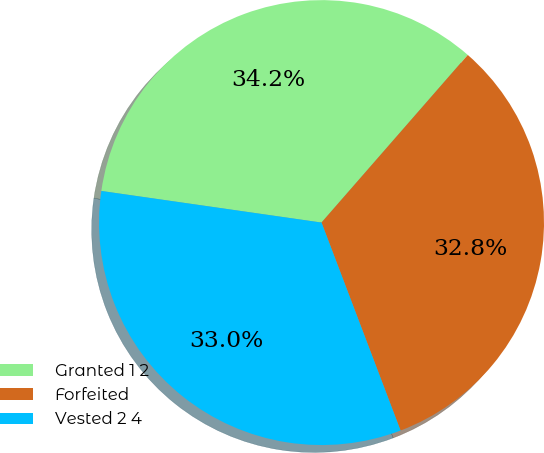Convert chart to OTSL. <chart><loc_0><loc_0><loc_500><loc_500><pie_chart><fcel>Granted 1 2<fcel>Forfeited<fcel>Vested 2 4<nl><fcel>34.15%<fcel>32.8%<fcel>33.05%<nl></chart> 